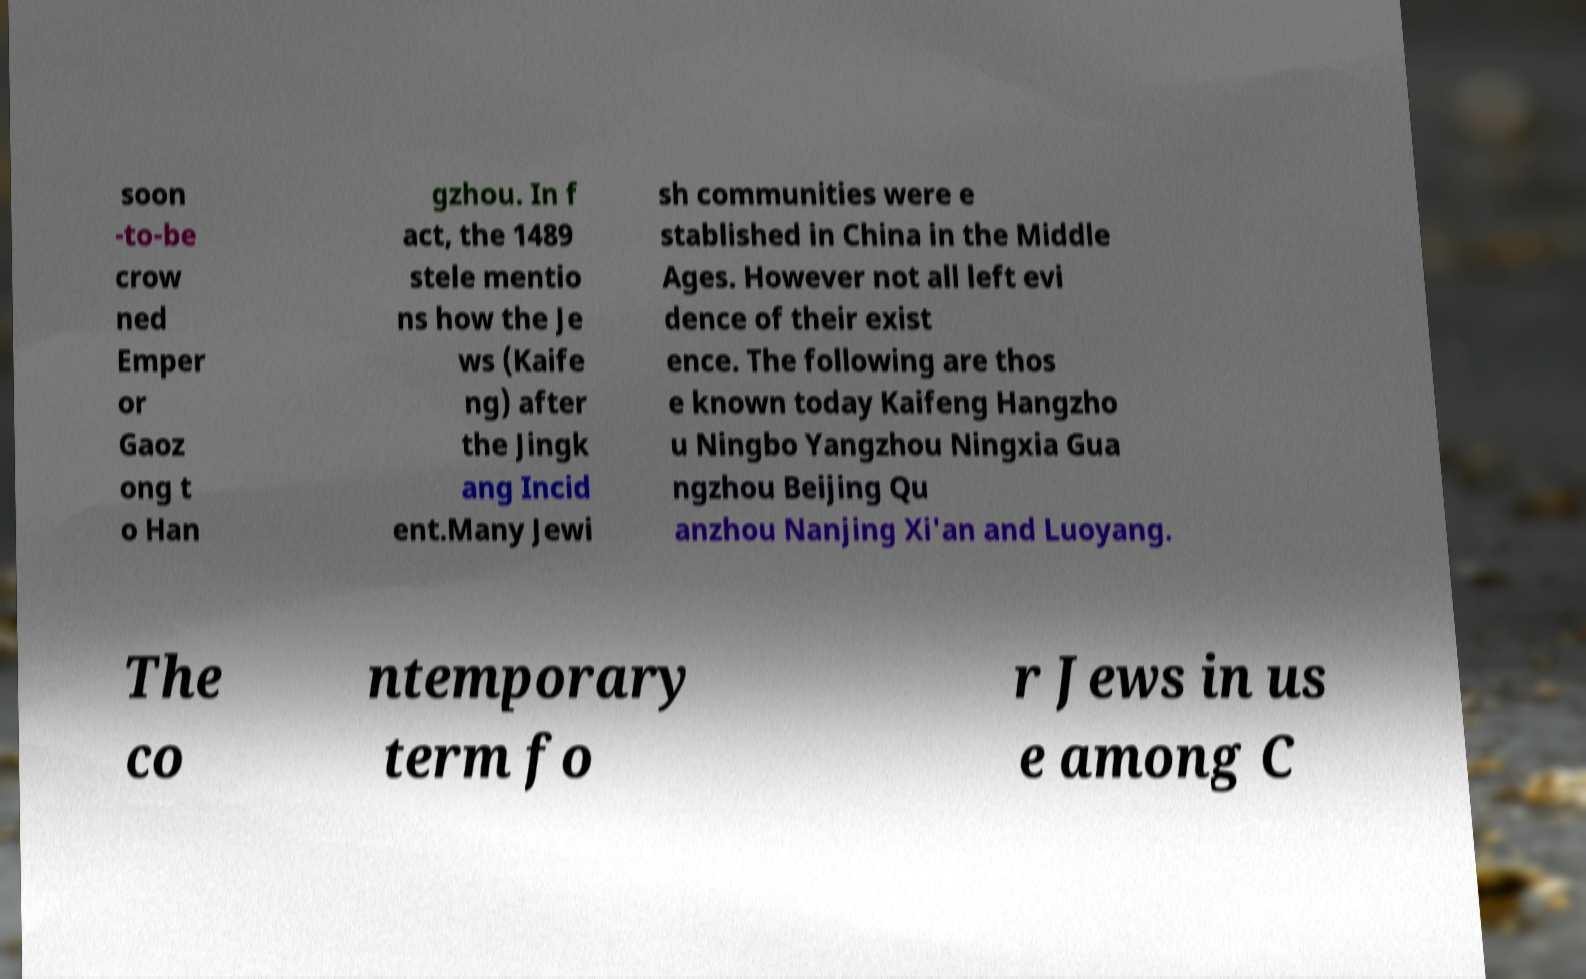What messages or text are displayed in this image? I need them in a readable, typed format. soon -to-be crow ned Emper or Gaoz ong t o Han gzhou. In f act, the 1489 stele mentio ns how the Je ws (Kaife ng) after the Jingk ang Incid ent.Many Jewi sh communities were e stablished in China in the Middle Ages. However not all left evi dence of their exist ence. The following are thos e known today Kaifeng Hangzho u Ningbo Yangzhou Ningxia Gua ngzhou Beijing Qu anzhou Nanjing Xi'an and Luoyang. The co ntemporary term fo r Jews in us e among C 